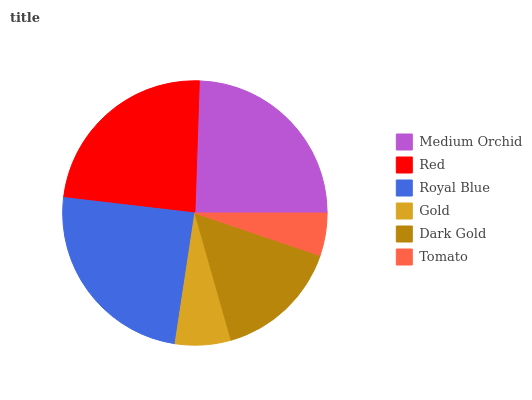Is Tomato the minimum?
Answer yes or no. Yes. Is Medium Orchid the maximum?
Answer yes or no. Yes. Is Red the minimum?
Answer yes or no. No. Is Red the maximum?
Answer yes or no. No. Is Medium Orchid greater than Red?
Answer yes or no. Yes. Is Red less than Medium Orchid?
Answer yes or no. Yes. Is Red greater than Medium Orchid?
Answer yes or no. No. Is Medium Orchid less than Red?
Answer yes or no. No. Is Red the high median?
Answer yes or no. Yes. Is Dark Gold the low median?
Answer yes or no. Yes. Is Gold the high median?
Answer yes or no. No. Is Royal Blue the low median?
Answer yes or no. No. 